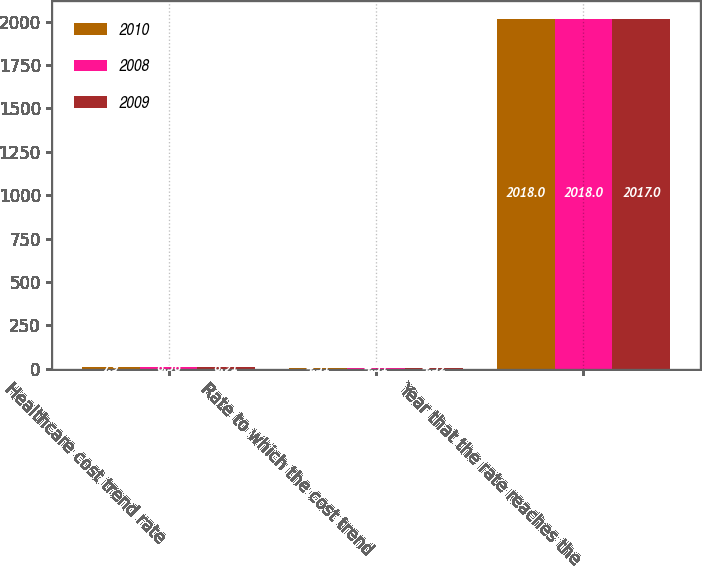Convert chart. <chart><loc_0><loc_0><loc_500><loc_500><stacked_bar_chart><ecel><fcel>Healthcare cost trend rate<fcel>Rate to which the cost trend<fcel>Year that the rate reaches the<nl><fcel>2010<fcel>7.9<fcel>4.51<fcel>2018<nl><fcel>2008<fcel>8.38<fcel>4.51<fcel>2018<nl><fcel>2009<fcel>8.91<fcel>4.52<fcel>2017<nl></chart> 